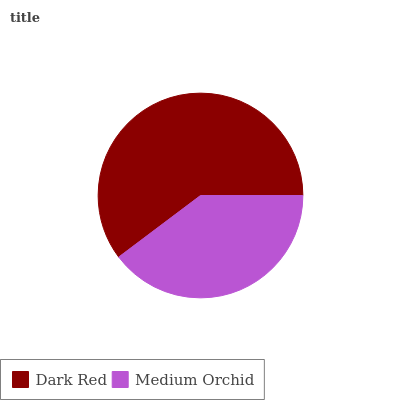Is Medium Orchid the minimum?
Answer yes or no. Yes. Is Dark Red the maximum?
Answer yes or no. Yes. Is Medium Orchid the maximum?
Answer yes or no. No. Is Dark Red greater than Medium Orchid?
Answer yes or no. Yes. Is Medium Orchid less than Dark Red?
Answer yes or no. Yes. Is Medium Orchid greater than Dark Red?
Answer yes or no. No. Is Dark Red less than Medium Orchid?
Answer yes or no. No. Is Dark Red the high median?
Answer yes or no. Yes. Is Medium Orchid the low median?
Answer yes or no. Yes. Is Medium Orchid the high median?
Answer yes or no. No. Is Dark Red the low median?
Answer yes or no. No. 